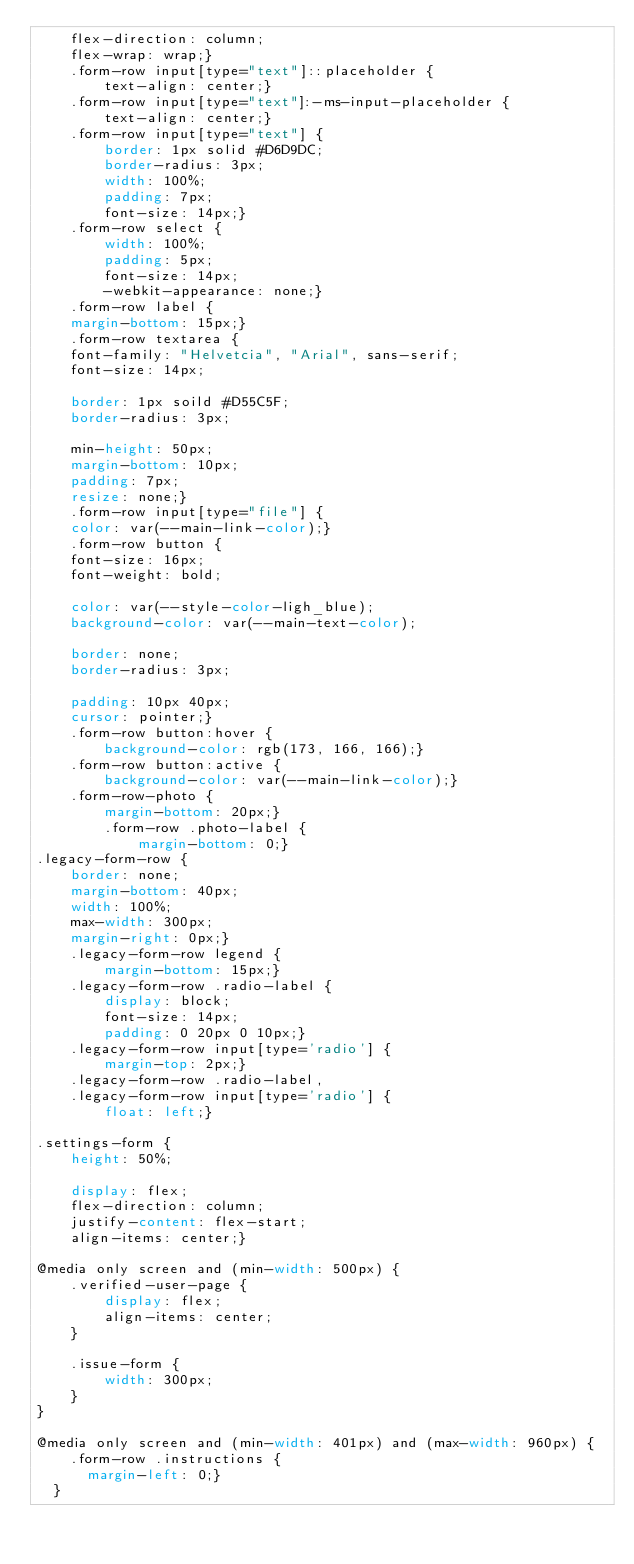Convert code to text. <code><loc_0><loc_0><loc_500><loc_500><_CSS_>    flex-direction: column;
    flex-wrap: wrap;}
    .form-row input[type="text"]::placeholder {
        text-align: center;}
    .form-row input[type="text"]:-ms-input-placeholder {
        text-align: center;}
    .form-row input[type="text"] {
        border: 1px solid #D6D9DC;
        border-radius: 3px;
        width: 100%;
        padding: 7px;
        font-size: 14px;}
    .form-row select {
        width: 100%;
        padding: 5px;
        font-size: 14px;
        -webkit-appearance: none;}
    .form-row label {
    margin-bottom: 15px;}
    .form-row textarea {
    font-family: "Helvetcia", "Arial", sans-serif;
    font-size: 14px;

    border: 1px soild #D55C5F;
    border-radius: 3px;

    min-height: 50px;
    margin-bottom: 10px;
    padding: 7px;
    resize: none;}
    .form-row input[type="file"] {
    color: var(--main-link-color);}
    .form-row button {
    font-size: 16px;
    font-weight: bold;

    color: var(--style-color-ligh_blue);
    background-color: var(--main-text-color);

    border: none;
    border-radius: 3px;

    padding: 10px 40px;
    cursor: pointer;}
    .form-row button:hover {
        background-color: rgb(173, 166, 166);}
    .form-row button:active {
        background-color: var(--main-link-color);}
    .form-row-photo {
        margin-bottom: 20px;}
        .form-row .photo-label {
            margin-bottom: 0;}
.legacy-form-row {
    border: none;
    margin-bottom: 40px;
    width: 100%;
    max-width: 300px;
    margin-right: 0px;}
    .legacy-form-row legend {
        margin-bottom: 15px;}
    .legacy-form-row .radio-label {
        display: block;
        font-size: 14px;
        padding: 0 20px 0 10px;}
    .legacy-form-row input[type='radio'] {
        margin-top: 2px;}
    .legacy-form-row .radio-label,
    .legacy-form-row input[type='radio'] {
        float: left;}

.settings-form {
    height: 50%;

    display: flex;
    flex-direction: column;
    justify-content: flex-start;
    align-items: center;}

@media only screen and (min-width: 500px) {
    .verified-user-page {
        display: flex;
        align-items: center;
    }

    .issue-form {
        width: 300px;
    }
}

@media only screen and (min-width: 401px) and (max-width: 960px) {
    .form-row .instructions {
      margin-left: 0;}
  }</code> 